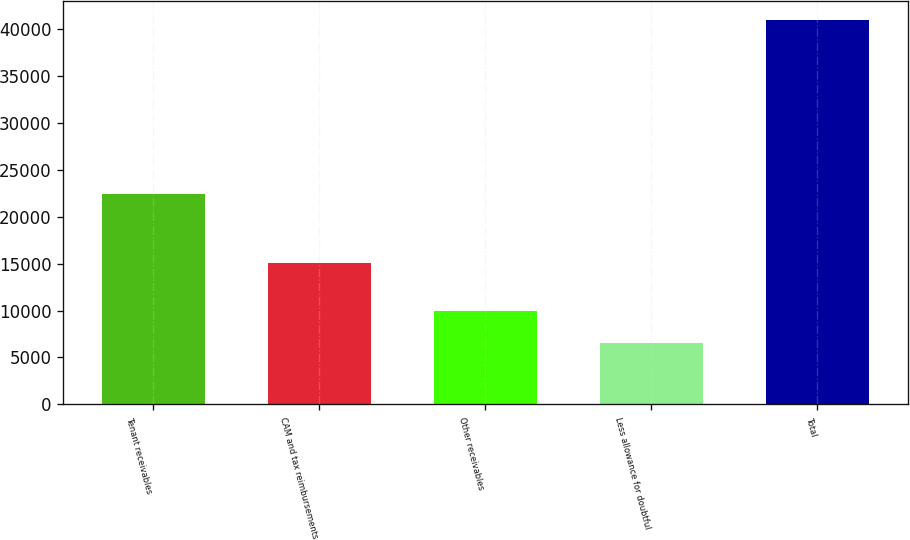<chart> <loc_0><loc_0><loc_500><loc_500><bar_chart><fcel>Tenant receivables<fcel>CAM and tax reimbursements<fcel>Other receivables<fcel>Less allowance for doubtful<fcel>Total<nl><fcel>22395<fcel>15099<fcel>9997.4<fcel>6567<fcel>40871<nl></chart> 